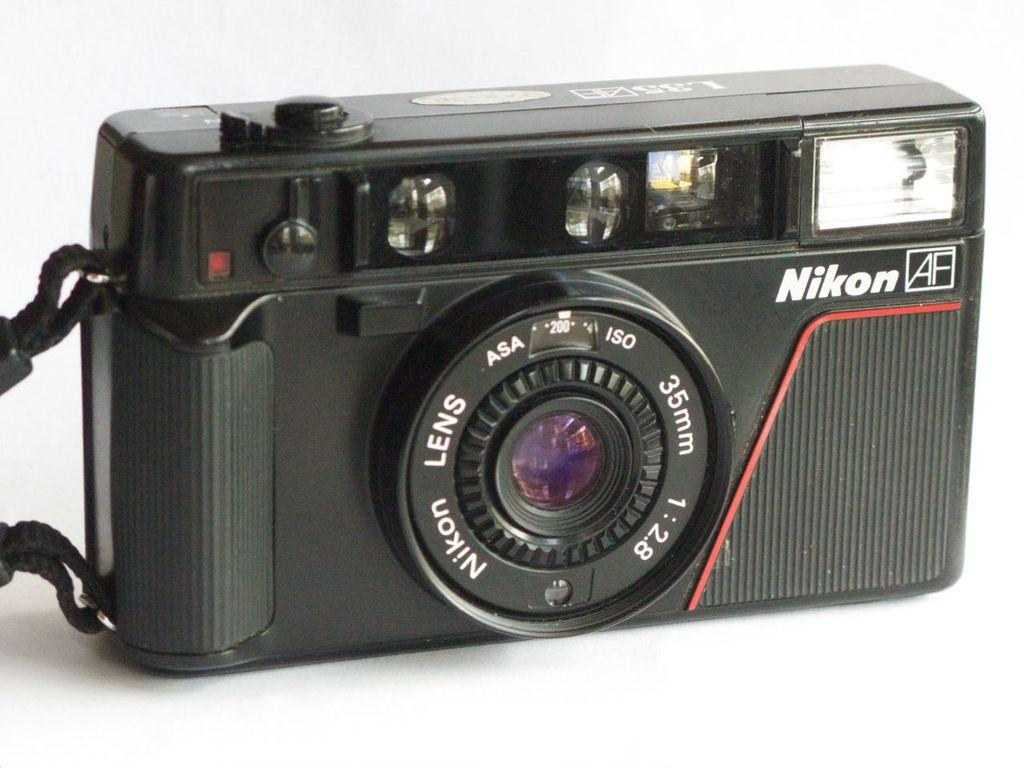What object is the main focus of the image? There is a camera in the image. What color is the background of the image? The background of the image is white. What type of oil is being used to lubricate the camera in the image? There is no indication in the image that the camera is being lubricated with oil, and therefore no such activity can be observed. 